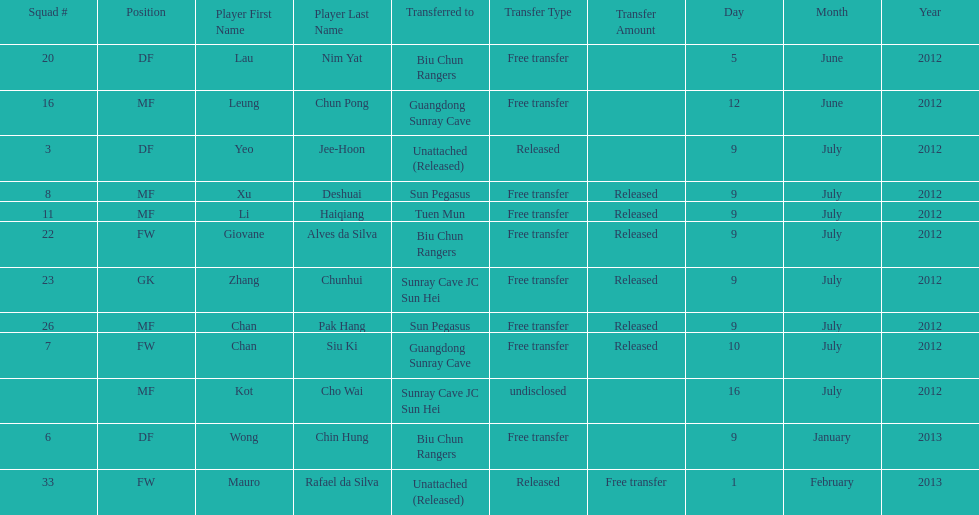Which team did lau nim yat play for after he was transferred? Biu Chun Rangers. 